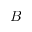<formula> <loc_0><loc_0><loc_500><loc_500>B</formula> 